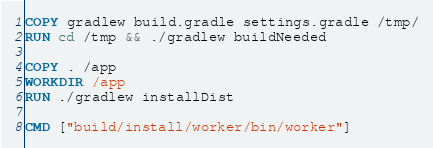<code> <loc_0><loc_0><loc_500><loc_500><_Dockerfile_>COPY gradlew build.gradle settings.gradle /tmp/
RUN cd /tmp && ./gradlew buildNeeded

COPY . /app
WORKDIR /app
RUN ./gradlew installDist

CMD ["build/install/worker/bin/worker"]
</code> 